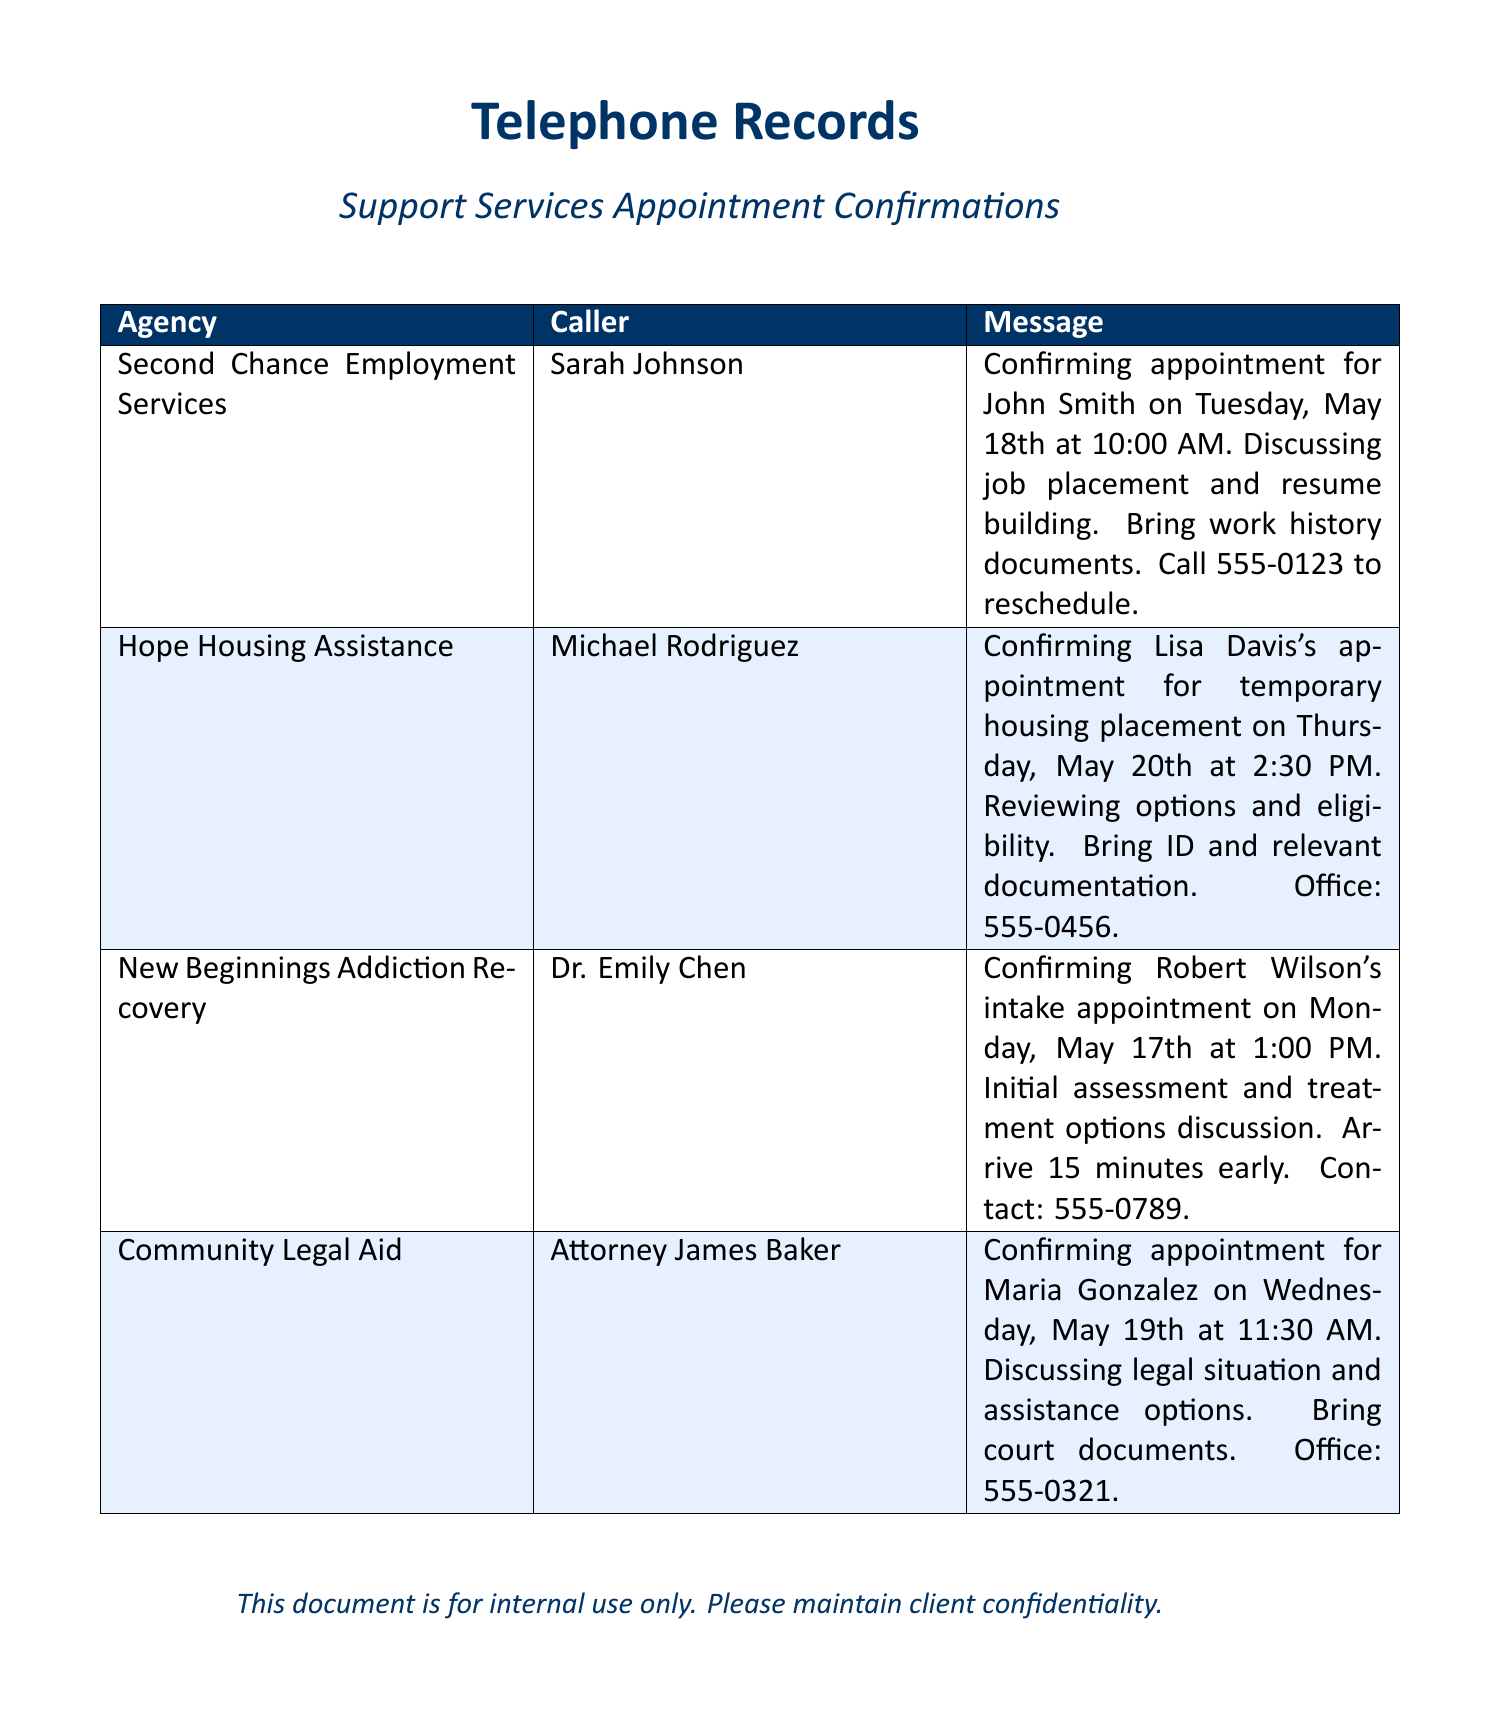What is the appointment date for John Smith? The appointment for John Smith is confirmed for Tuesday, May 18th.
Answer: Tuesday, May 18th What time is Lisa Davis's appointment? Lisa Davis's appointment is scheduled for 2:30 PM.
Answer: 2:30 PM Who is the caller for the intake appointment of Robert Wilson? The caller for Robert Wilson's intake appointment is Dr. Emily Chen.
Answer: Dr. Emily Chen What should Maria Gonzalez bring to her appointment? Maria Gonzalez should bring court documents to her appointment.
Answer: court documents How many clients are mentioned in the document? There are four clients mentioned in the document: John Smith, Lisa Davis, Robert Wilson, and Maria Gonzalez.
Answer: four clients What is the primary purpose of New Beginnings Addiction Recovery's appointment? The primary purpose is to discuss initial assessment and treatment options.
Answer: initial assessment and treatment options Which agency is confirming an appointment for temporary housing placement? Hope Housing Assistance is confirming the appointment for temporary housing placement.
Answer: Hope Housing Assistance What is the phone number for Second Chance Employment Services? The phone number to reschedule is 555-0123.
Answer: 555-0123 